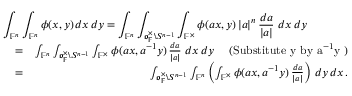Convert formula to latex. <formula><loc_0><loc_0><loc_500><loc_500>\begin{array} { r l r } { { \int _ { \mathbb { F } ^ { n } } \int _ { \mathbb { F } ^ { n } } \phi ( x , y ) \, d x \, d y = \int _ { \mathbb { F } ^ { n } } \int _ { \mathfrak o _ { \mathbb { F } } ^ { \times } \ S ^ { n - 1 } } \int _ { \mathbb { F } ^ { \times } } \phi ( a x , y ) \, | a | ^ { n } \, \frac { d a } { | a | } \, d x \, d y } } \\ & { = } & { \int _ { \mathbb { F } ^ { n } } \int _ { \mathfrak o _ { \mathbb { F } } ^ { \times } \ S ^ { n - 1 } } \int _ { \mathbb { F } ^ { \times } } \phi ( a x , a ^ { - 1 } y ) \, \frac { d a } { | a | } \, d x \, d y \quad ( S u b s t i t u t e y b y a ^ { - 1 } y ) } \\ & { = } & { \int _ { \mathfrak o _ { \mathbb { F } } ^ { \times } \ S ^ { n - 1 } } \int _ { \mathbb { F } ^ { n } } \left ( \int _ { \mathbb { F } ^ { \times } } \phi ( a x , a ^ { - 1 } y ) \, \frac { d a } { | a | } \right ) \, d y \, d x \, . } \end{array}</formula> 